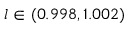<formula> <loc_0><loc_0><loc_500><loc_500>l \in ( 0 . 9 9 8 , 1 . 0 0 2 )</formula> 